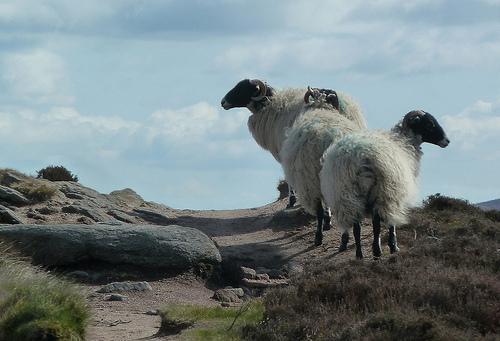How many sheep?
Give a very brief answer. 3. 